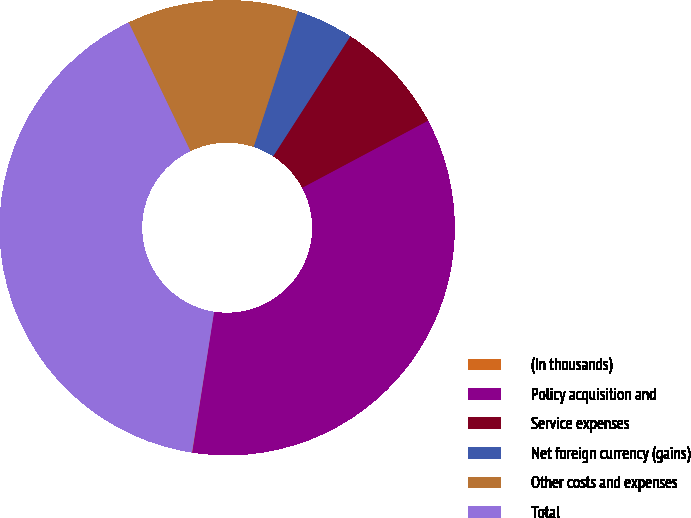Convert chart to OTSL. <chart><loc_0><loc_0><loc_500><loc_500><pie_chart><fcel>(In thousands)<fcel>Policy acquisition and<fcel>Service expenses<fcel>Net foreign currency (gains)<fcel>Other costs and expenses<fcel>Total<nl><fcel>0.03%<fcel>35.24%<fcel>8.11%<fcel>4.07%<fcel>12.15%<fcel>40.4%<nl></chart> 